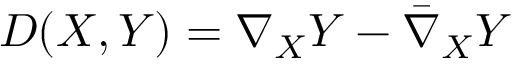Convert formula to latex. <formula><loc_0><loc_0><loc_500><loc_500>D ( X , Y ) = \nabla _ { X } Y - { \bar { \nabla } } _ { X } Y</formula> 